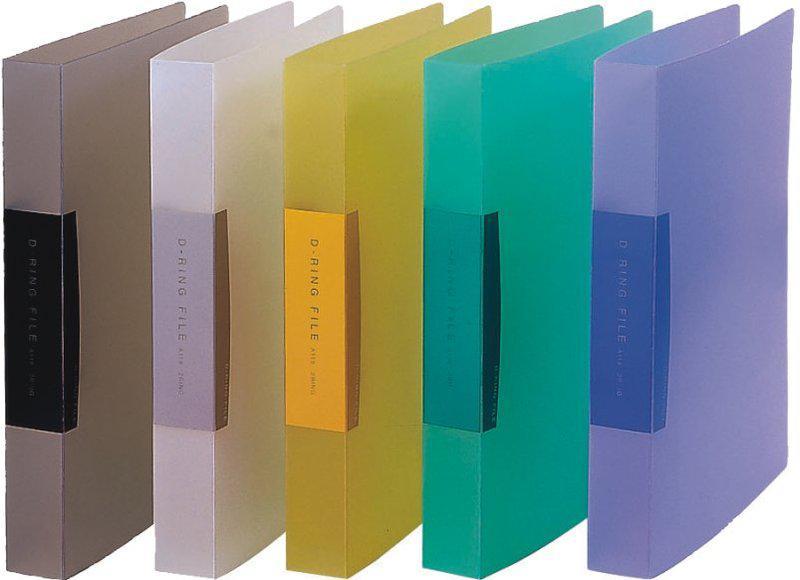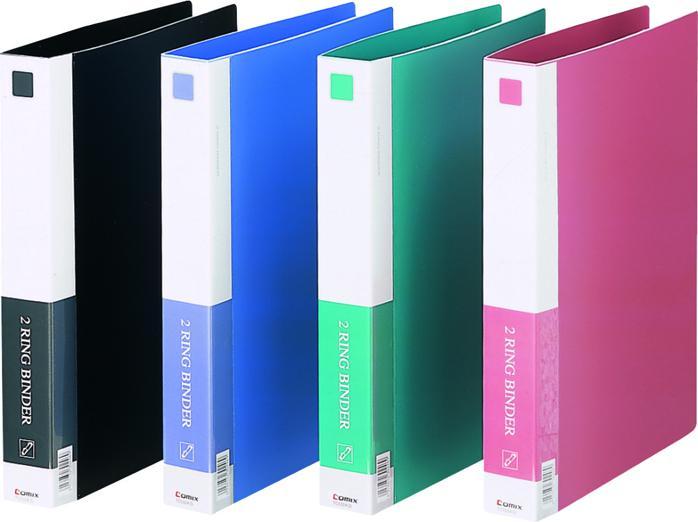The first image is the image on the left, the second image is the image on the right. Given the left and right images, does the statement "There are nine binders, all appearing to be different colors." hold true? Answer yes or no. Yes. 